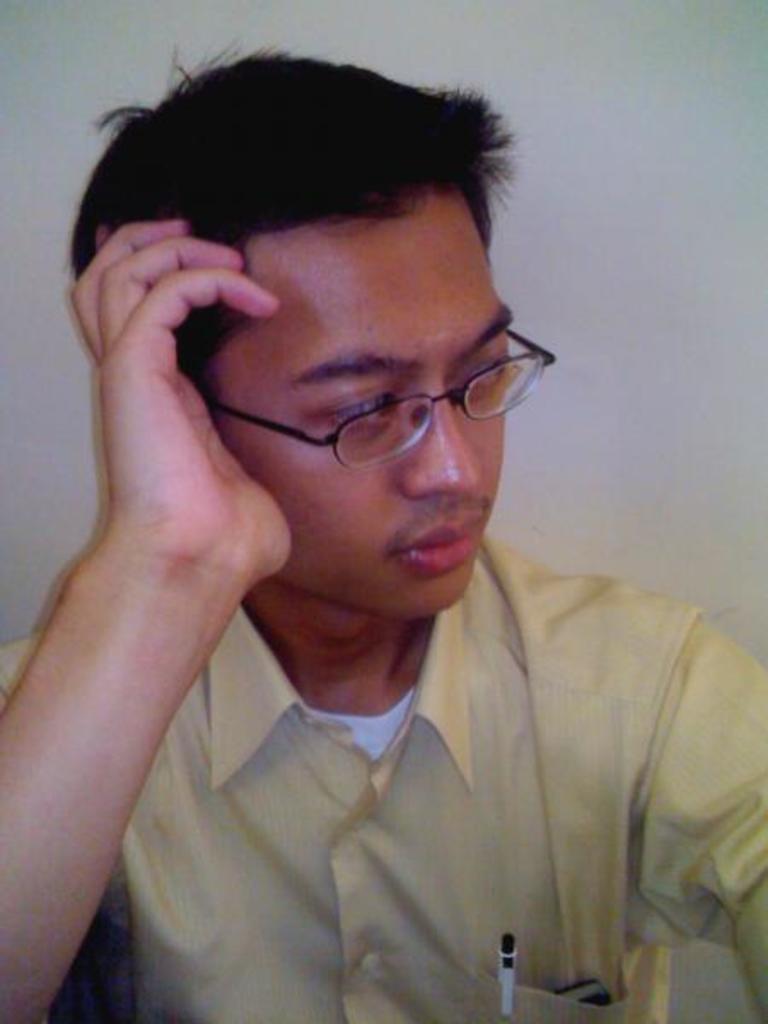In one or two sentences, can you explain what this image depicts? In this image we can see a person wearing yellow color shirt and there is mobile phone and pen in his pocket wearing spectacles sitting. 